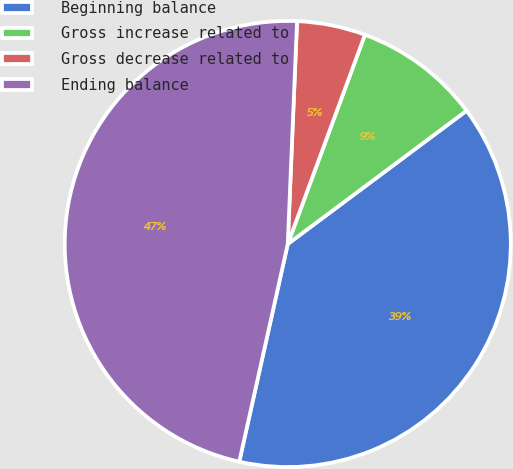Convert chart. <chart><loc_0><loc_0><loc_500><loc_500><pie_chart><fcel>Beginning balance<fcel>Gross increase related to<fcel>Gross decrease related to<fcel>Ending balance<nl><fcel>38.68%<fcel>9.18%<fcel>4.96%<fcel>47.17%<nl></chart> 